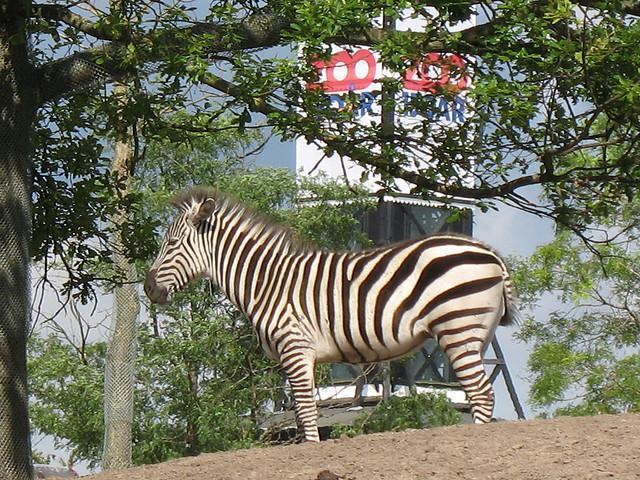How many animals are in the photo?
Give a very brief answer. 1. How many zebras are there?
Give a very brief answer. 1. How many people total are dining at this table?
Give a very brief answer. 0. 